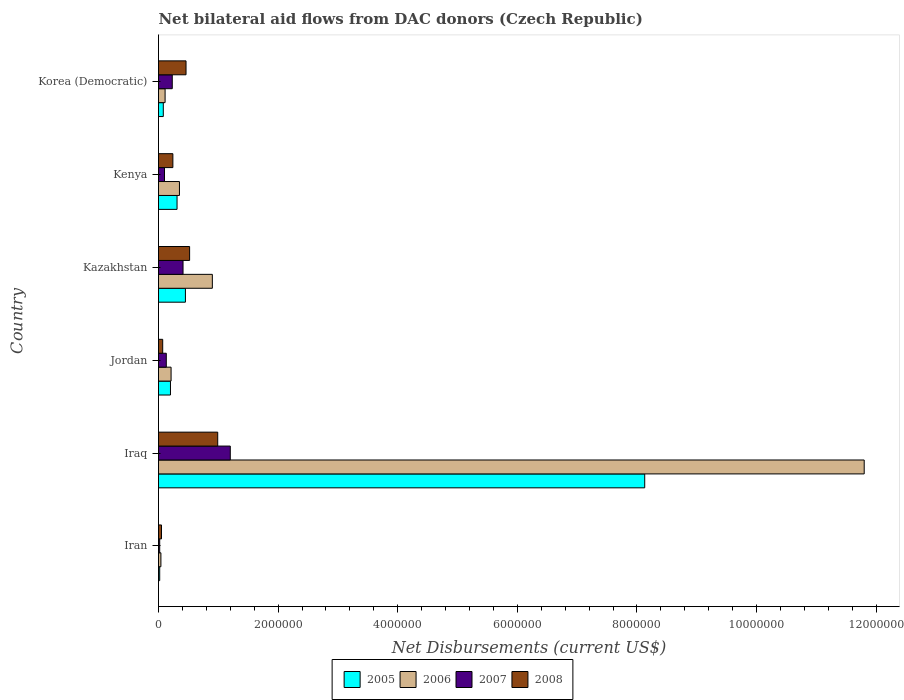How many groups of bars are there?
Your response must be concise. 6. Are the number of bars per tick equal to the number of legend labels?
Your answer should be very brief. Yes. How many bars are there on the 3rd tick from the bottom?
Your response must be concise. 4. What is the label of the 3rd group of bars from the top?
Provide a short and direct response. Kazakhstan. In how many cases, is the number of bars for a given country not equal to the number of legend labels?
Offer a very short reply. 0. What is the net bilateral aid flows in 2006 in Iraq?
Offer a very short reply. 1.18e+07. Across all countries, what is the maximum net bilateral aid flows in 2008?
Provide a succinct answer. 9.90e+05. In which country was the net bilateral aid flows in 2005 maximum?
Your answer should be compact. Iraq. In which country was the net bilateral aid flows in 2006 minimum?
Provide a succinct answer. Iran. What is the total net bilateral aid flows in 2006 in the graph?
Give a very brief answer. 1.34e+07. What is the difference between the net bilateral aid flows in 2005 in Jordan and that in Korea (Democratic)?
Your answer should be very brief. 1.20e+05. What is the difference between the net bilateral aid flows in 2008 in Kazakhstan and the net bilateral aid flows in 2005 in Korea (Democratic)?
Make the answer very short. 4.40e+05. What is the average net bilateral aid flows in 2007 per country?
Offer a terse response. 3.48e+05. In how many countries, is the net bilateral aid flows in 2005 greater than 8800000 US$?
Ensure brevity in your answer.  0. What is the ratio of the net bilateral aid flows in 2005 in Jordan to that in Kazakhstan?
Make the answer very short. 0.44. Is the difference between the net bilateral aid flows in 2005 in Iraq and Kazakhstan greater than the difference between the net bilateral aid flows in 2006 in Iraq and Kazakhstan?
Your answer should be very brief. No. What is the difference between the highest and the second highest net bilateral aid flows in 2008?
Your answer should be compact. 4.70e+05. What is the difference between the highest and the lowest net bilateral aid flows in 2007?
Keep it short and to the point. 1.18e+06. Is the sum of the net bilateral aid flows in 2006 in Kazakhstan and Kenya greater than the maximum net bilateral aid flows in 2007 across all countries?
Offer a very short reply. Yes. What does the 4th bar from the bottom in Kenya represents?
Provide a succinct answer. 2008. How many countries are there in the graph?
Your response must be concise. 6. What is the difference between two consecutive major ticks on the X-axis?
Your response must be concise. 2.00e+06. Does the graph contain grids?
Provide a succinct answer. No. Where does the legend appear in the graph?
Offer a very short reply. Bottom center. How many legend labels are there?
Your answer should be compact. 4. What is the title of the graph?
Make the answer very short. Net bilateral aid flows from DAC donors (Czech Republic). What is the label or title of the X-axis?
Your response must be concise. Net Disbursements (current US$). What is the Net Disbursements (current US$) in 2005 in Iran?
Your answer should be very brief. 2.00e+04. What is the Net Disbursements (current US$) in 2006 in Iran?
Keep it short and to the point. 4.00e+04. What is the Net Disbursements (current US$) of 2008 in Iran?
Provide a succinct answer. 5.00e+04. What is the Net Disbursements (current US$) in 2005 in Iraq?
Make the answer very short. 8.13e+06. What is the Net Disbursements (current US$) of 2006 in Iraq?
Provide a succinct answer. 1.18e+07. What is the Net Disbursements (current US$) in 2007 in Iraq?
Provide a succinct answer. 1.20e+06. What is the Net Disbursements (current US$) of 2008 in Iraq?
Ensure brevity in your answer.  9.90e+05. What is the Net Disbursements (current US$) in 2005 in Jordan?
Offer a terse response. 2.00e+05. What is the Net Disbursements (current US$) of 2007 in Jordan?
Offer a terse response. 1.30e+05. What is the Net Disbursements (current US$) of 2005 in Kazakhstan?
Provide a succinct answer. 4.50e+05. What is the Net Disbursements (current US$) in 2006 in Kazakhstan?
Your answer should be very brief. 9.00e+05. What is the Net Disbursements (current US$) of 2008 in Kazakhstan?
Your answer should be compact. 5.20e+05. What is the Net Disbursements (current US$) of 2006 in Kenya?
Provide a succinct answer. 3.50e+05. What is the Net Disbursements (current US$) of 2007 in Korea (Democratic)?
Give a very brief answer. 2.30e+05. Across all countries, what is the maximum Net Disbursements (current US$) of 2005?
Offer a very short reply. 8.13e+06. Across all countries, what is the maximum Net Disbursements (current US$) in 2006?
Your answer should be very brief. 1.18e+07. Across all countries, what is the maximum Net Disbursements (current US$) of 2007?
Your answer should be compact. 1.20e+06. Across all countries, what is the maximum Net Disbursements (current US$) in 2008?
Your answer should be very brief. 9.90e+05. Across all countries, what is the minimum Net Disbursements (current US$) in 2005?
Offer a very short reply. 2.00e+04. Across all countries, what is the minimum Net Disbursements (current US$) of 2006?
Your answer should be compact. 4.00e+04. Across all countries, what is the minimum Net Disbursements (current US$) in 2007?
Make the answer very short. 2.00e+04. Across all countries, what is the minimum Net Disbursements (current US$) in 2008?
Provide a succinct answer. 5.00e+04. What is the total Net Disbursements (current US$) of 2005 in the graph?
Your answer should be compact. 9.19e+06. What is the total Net Disbursements (current US$) of 2006 in the graph?
Keep it short and to the point. 1.34e+07. What is the total Net Disbursements (current US$) of 2007 in the graph?
Make the answer very short. 2.09e+06. What is the total Net Disbursements (current US$) of 2008 in the graph?
Provide a succinct answer. 2.33e+06. What is the difference between the Net Disbursements (current US$) in 2005 in Iran and that in Iraq?
Ensure brevity in your answer.  -8.11e+06. What is the difference between the Net Disbursements (current US$) in 2006 in Iran and that in Iraq?
Make the answer very short. -1.18e+07. What is the difference between the Net Disbursements (current US$) of 2007 in Iran and that in Iraq?
Offer a very short reply. -1.18e+06. What is the difference between the Net Disbursements (current US$) of 2008 in Iran and that in Iraq?
Provide a succinct answer. -9.40e+05. What is the difference between the Net Disbursements (current US$) of 2005 in Iran and that in Jordan?
Your answer should be compact. -1.80e+05. What is the difference between the Net Disbursements (current US$) of 2006 in Iran and that in Jordan?
Your response must be concise. -1.70e+05. What is the difference between the Net Disbursements (current US$) in 2008 in Iran and that in Jordan?
Ensure brevity in your answer.  -2.00e+04. What is the difference between the Net Disbursements (current US$) of 2005 in Iran and that in Kazakhstan?
Provide a short and direct response. -4.30e+05. What is the difference between the Net Disbursements (current US$) of 2006 in Iran and that in Kazakhstan?
Provide a succinct answer. -8.60e+05. What is the difference between the Net Disbursements (current US$) of 2007 in Iran and that in Kazakhstan?
Your answer should be compact. -3.90e+05. What is the difference between the Net Disbursements (current US$) of 2008 in Iran and that in Kazakhstan?
Your answer should be compact. -4.70e+05. What is the difference between the Net Disbursements (current US$) in 2006 in Iran and that in Kenya?
Provide a short and direct response. -3.10e+05. What is the difference between the Net Disbursements (current US$) in 2007 in Iran and that in Kenya?
Offer a terse response. -8.00e+04. What is the difference between the Net Disbursements (current US$) in 2005 in Iran and that in Korea (Democratic)?
Provide a succinct answer. -6.00e+04. What is the difference between the Net Disbursements (current US$) in 2006 in Iran and that in Korea (Democratic)?
Your answer should be compact. -7.00e+04. What is the difference between the Net Disbursements (current US$) of 2007 in Iran and that in Korea (Democratic)?
Offer a very short reply. -2.10e+05. What is the difference between the Net Disbursements (current US$) of 2008 in Iran and that in Korea (Democratic)?
Make the answer very short. -4.10e+05. What is the difference between the Net Disbursements (current US$) of 2005 in Iraq and that in Jordan?
Your answer should be very brief. 7.93e+06. What is the difference between the Net Disbursements (current US$) in 2006 in Iraq and that in Jordan?
Your answer should be very brief. 1.16e+07. What is the difference between the Net Disbursements (current US$) in 2007 in Iraq and that in Jordan?
Your response must be concise. 1.07e+06. What is the difference between the Net Disbursements (current US$) of 2008 in Iraq and that in Jordan?
Your answer should be compact. 9.20e+05. What is the difference between the Net Disbursements (current US$) of 2005 in Iraq and that in Kazakhstan?
Provide a succinct answer. 7.68e+06. What is the difference between the Net Disbursements (current US$) of 2006 in Iraq and that in Kazakhstan?
Provide a succinct answer. 1.09e+07. What is the difference between the Net Disbursements (current US$) in 2007 in Iraq and that in Kazakhstan?
Your answer should be very brief. 7.90e+05. What is the difference between the Net Disbursements (current US$) of 2005 in Iraq and that in Kenya?
Provide a succinct answer. 7.82e+06. What is the difference between the Net Disbursements (current US$) of 2006 in Iraq and that in Kenya?
Keep it short and to the point. 1.14e+07. What is the difference between the Net Disbursements (current US$) of 2007 in Iraq and that in Kenya?
Provide a short and direct response. 1.10e+06. What is the difference between the Net Disbursements (current US$) of 2008 in Iraq and that in Kenya?
Your answer should be very brief. 7.50e+05. What is the difference between the Net Disbursements (current US$) in 2005 in Iraq and that in Korea (Democratic)?
Offer a very short reply. 8.05e+06. What is the difference between the Net Disbursements (current US$) in 2006 in Iraq and that in Korea (Democratic)?
Provide a succinct answer. 1.17e+07. What is the difference between the Net Disbursements (current US$) in 2007 in Iraq and that in Korea (Democratic)?
Ensure brevity in your answer.  9.70e+05. What is the difference between the Net Disbursements (current US$) of 2008 in Iraq and that in Korea (Democratic)?
Provide a succinct answer. 5.30e+05. What is the difference between the Net Disbursements (current US$) in 2006 in Jordan and that in Kazakhstan?
Ensure brevity in your answer.  -6.90e+05. What is the difference between the Net Disbursements (current US$) in 2007 in Jordan and that in Kazakhstan?
Offer a very short reply. -2.80e+05. What is the difference between the Net Disbursements (current US$) of 2008 in Jordan and that in Kazakhstan?
Keep it short and to the point. -4.50e+05. What is the difference between the Net Disbursements (current US$) in 2005 in Jordan and that in Korea (Democratic)?
Provide a short and direct response. 1.20e+05. What is the difference between the Net Disbursements (current US$) in 2006 in Jordan and that in Korea (Democratic)?
Your response must be concise. 1.00e+05. What is the difference between the Net Disbursements (current US$) in 2008 in Jordan and that in Korea (Democratic)?
Offer a very short reply. -3.90e+05. What is the difference between the Net Disbursements (current US$) of 2006 in Kazakhstan and that in Kenya?
Provide a short and direct response. 5.50e+05. What is the difference between the Net Disbursements (current US$) of 2007 in Kazakhstan and that in Kenya?
Your response must be concise. 3.10e+05. What is the difference between the Net Disbursements (current US$) of 2006 in Kazakhstan and that in Korea (Democratic)?
Give a very brief answer. 7.90e+05. What is the difference between the Net Disbursements (current US$) of 2007 in Kazakhstan and that in Korea (Democratic)?
Your answer should be compact. 1.80e+05. What is the difference between the Net Disbursements (current US$) in 2008 in Kazakhstan and that in Korea (Democratic)?
Offer a terse response. 6.00e+04. What is the difference between the Net Disbursements (current US$) in 2006 in Kenya and that in Korea (Democratic)?
Your answer should be very brief. 2.40e+05. What is the difference between the Net Disbursements (current US$) in 2008 in Kenya and that in Korea (Democratic)?
Make the answer very short. -2.20e+05. What is the difference between the Net Disbursements (current US$) of 2005 in Iran and the Net Disbursements (current US$) of 2006 in Iraq?
Keep it short and to the point. -1.18e+07. What is the difference between the Net Disbursements (current US$) in 2005 in Iran and the Net Disbursements (current US$) in 2007 in Iraq?
Ensure brevity in your answer.  -1.18e+06. What is the difference between the Net Disbursements (current US$) of 2005 in Iran and the Net Disbursements (current US$) of 2008 in Iraq?
Offer a very short reply. -9.70e+05. What is the difference between the Net Disbursements (current US$) in 2006 in Iran and the Net Disbursements (current US$) in 2007 in Iraq?
Your response must be concise. -1.16e+06. What is the difference between the Net Disbursements (current US$) in 2006 in Iran and the Net Disbursements (current US$) in 2008 in Iraq?
Your response must be concise. -9.50e+05. What is the difference between the Net Disbursements (current US$) in 2007 in Iran and the Net Disbursements (current US$) in 2008 in Iraq?
Give a very brief answer. -9.70e+05. What is the difference between the Net Disbursements (current US$) of 2005 in Iran and the Net Disbursements (current US$) of 2006 in Jordan?
Your answer should be very brief. -1.90e+05. What is the difference between the Net Disbursements (current US$) in 2005 in Iran and the Net Disbursements (current US$) in 2008 in Jordan?
Your answer should be compact. -5.00e+04. What is the difference between the Net Disbursements (current US$) in 2006 in Iran and the Net Disbursements (current US$) in 2007 in Jordan?
Your response must be concise. -9.00e+04. What is the difference between the Net Disbursements (current US$) in 2006 in Iran and the Net Disbursements (current US$) in 2008 in Jordan?
Offer a very short reply. -3.00e+04. What is the difference between the Net Disbursements (current US$) in 2005 in Iran and the Net Disbursements (current US$) in 2006 in Kazakhstan?
Give a very brief answer. -8.80e+05. What is the difference between the Net Disbursements (current US$) of 2005 in Iran and the Net Disbursements (current US$) of 2007 in Kazakhstan?
Offer a very short reply. -3.90e+05. What is the difference between the Net Disbursements (current US$) in 2005 in Iran and the Net Disbursements (current US$) in 2008 in Kazakhstan?
Offer a terse response. -5.00e+05. What is the difference between the Net Disbursements (current US$) of 2006 in Iran and the Net Disbursements (current US$) of 2007 in Kazakhstan?
Provide a short and direct response. -3.70e+05. What is the difference between the Net Disbursements (current US$) in 2006 in Iran and the Net Disbursements (current US$) in 2008 in Kazakhstan?
Offer a terse response. -4.80e+05. What is the difference between the Net Disbursements (current US$) of 2007 in Iran and the Net Disbursements (current US$) of 2008 in Kazakhstan?
Offer a terse response. -5.00e+05. What is the difference between the Net Disbursements (current US$) of 2005 in Iran and the Net Disbursements (current US$) of 2006 in Kenya?
Make the answer very short. -3.30e+05. What is the difference between the Net Disbursements (current US$) in 2005 in Iran and the Net Disbursements (current US$) in 2007 in Kenya?
Make the answer very short. -8.00e+04. What is the difference between the Net Disbursements (current US$) in 2005 in Iran and the Net Disbursements (current US$) in 2008 in Kenya?
Provide a succinct answer. -2.20e+05. What is the difference between the Net Disbursements (current US$) of 2006 in Iran and the Net Disbursements (current US$) of 2007 in Kenya?
Your answer should be compact. -6.00e+04. What is the difference between the Net Disbursements (current US$) of 2007 in Iran and the Net Disbursements (current US$) of 2008 in Kenya?
Keep it short and to the point. -2.20e+05. What is the difference between the Net Disbursements (current US$) in 2005 in Iran and the Net Disbursements (current US$) in 2006 in Korea (Democratic)?
Keep it short and to the point. -9.00e+04. What is the difference between the Net Disbursements (current US$) of 2005 in Iran and the Net Disbursements (current US$) of 2008 in Korea (Democratic)?
Offer a terse response. -4.40e+05. What is the difference between the Net Disbursements (current US$) of 2006 in Iran and the Net Disbursements (current US$) of 2007 in Korea (Democratic)?
Provide a succinct answer. -1.90e+05. What is the difference between the Net Disbursements (current US$) of 2006 in Iran and the Net Disbursements (current US$) of 2008 in Korea (Democratic)?
Your answer should be very brief. -4.20e+05. What is the difference between the Net Disbursements (current US$) of 2007 in Iran and the Net Disbursements (current US$) of 2008 in Korea (Democratic)?
Ensure brevity in your answer.  -4.40e+05. What is the difference between the Net Disbursements (current US$) in 2005 in Iraq and the Net Disbursements (current US$) in 2006 in Jordan?
Offer a terse response. 7.92e+06. What is the difference between the Net Disbursements (current US$) of 2005 in Iraq and the Net Disbursements (current US$) of 2007 in Jordan?
Offer a very short reply. 8.00e+06. What is the difference between the Net Disbursements (current US$) of 2005 in Iraq and the Net Disbursements (current US$) of 2008 in Jordan?
Offer a very short reply. 8.06e+06. What is the difference between the Net Disbursements (current US$) of 2006 in Iraq and the Net Disbursements (current US$) of 2007 in Jordan?
Your answer should be compact. 1.17e+07. What is the difference between the Net Disbursements (current US$) of 2006 in Iraq and the Net Disbursements (current US$) of 2008 in Jordan?
Keep it short and to the point. 1.17e+07. What is the difference between the Net Disbursements (current US$) in 2007 in Iraq and the Net Disbursements (current US$) in 2008 in Jordan?
Provide a short and direct response. 1.13e+06. What is the difference between the Net Disbursements (current US$) in 2005 in Iraq and the Net Disbursements (current US$) in 2006 in Kazakhstan?
Your response must be concise. 7.23e+06. What is the difference between the Net Disbursements (current US$) in 2005 in Iraq and the Net Disbursements (current US$) in 2007 in Kazakhstan?
Provide a short and direct response. 7.72e+06. What is the difference between the Net Disbursements (current US$) of 2005 in Iraq and the Net Disbursements (current US$) of 2008 in Kazakhstan?
Your answer should be very brief. 7.61e+06. What is the difference between the Net Disbursements (current US$) in 2006 in Iraq and the Net Disbursements (current US$) in 2007 in Kazakhstan?
Your answer should be compact. 1.14e+07. What is the difference between the Net Disbursements (current US$) of 2006 in Iraq and the Net Disbursements (current US$) of 2008 in Kazakhstan?
Your response must be concise. 1.13e+07. What is the difference between the Net Disbursements (current US$) in 2007 in Iraq and the Net Disbursements (current US$) in 2008 in Kazakhstan?
Your answer should be very brief. 6.80e+05. What is the difference between the Net Disbursements (current US$) in 2005 in Iraq and the Net Disbursements (current US$) in 2006 in Kenya?
Your answer should be compact. 7.78e+06. What is the difference between the Net Disbursements (current US$) of 2005 in Iraq and the Net Disbursements (current US$) of 2007 in Kenya?
Give a very brief answer. 8.03e+06. What is the difference between the Net Disbursements (current US$) in 2005 in Iraq and the Net Disbursements (current US$) in 2008 in Kenya?
Give a very brief answer. 7.89e+06. What is the difference between the Net Disbursements (current US$) in 2006 in Iraq and the Net Disbursements (current US$) in 2007 in Kenya?
Your answer should be very brief. 1.17e+07. What is the difference between the Net Disbursements (current US$) of 2006 in Iraq and the Net Disbursements (current US$) of 2008 in Kenya?
Make the answer very short. 1.16e+07. What is the difference between the Net Disbursements (current US$) of 2007 in Iraq and the Net Disbursements (current US$) of 2008 in Kenya?
Your answer should be very brief. 9.60e+05. What is the difference between the Net Disbursements (current US$) of 2005 in Iraq and the Net Disbursements (current US$) of 2006 in Korea (Democratic)?
Give a very brief answer. 8.02e+06. What is the difference between the Net Disbursements (current US$) of 2005 in Iraq and the Net Disbursements (current US$) of 2007 in Korea (Democratic)?
Keep it short and to the point. 7.90e+06. What is the difference between the Net Disbursements (current US$) in 2005 in Iraq and the Net Disbursements (current US$) in 2008 in Korea (Democratic)?
Give a very brief answer. 7.67e+06. What is the difference between the Net Disbursements (current US$) of 2006 in Iraq and the Net Disbursements (current US$) of 2007 in Korea (Democratic)?
Provide a succinct answer. 1.16e+07. What is the difference between the Net Disbursements (current US$) in 2006 in Iraq and the Net Disbursements (current US$) in 2008 in Korea (Democratic)?
Give a very brief answer. 1.13e+07. What is the difference between the Net Disbursements (current US$) of 2007 in Iraq and the Net Disbursements (current US$) of 2008 in Korea (Democratic)?
Provide a succinct answer. 7.40e+05. What is the difference between the Net Disbursements (current US$) of 2005 in Jordan and the Net Disbursements (current US$) of 2006 in Kazakhstan?
Your answer should be compact. -7.00e+05. What is the difference between the Net Disbursements (current US$) of 2005 in Jordan and the Net Disbursements (current US$) of 2007 in Kazakhstan?
Keep it short and to the point. -2.10e+05. What is the difference between the Net Disbursements (current US$) in 2005 in Jordan and the Net Disbursements (current US$) in 2008 in Kazakhstan?
Offer a terse response. -3.20e+05. What is the difference between the Net Disbursements (current US$) in 2006 in Jordan and the Net Disbursements (current US$) in 2008 in Kazakhstan?
Offer a very short reply. -3.10e+05. What is the difference between the Net Disbursements (current US$) in 2007 in Jordan and the Net Disbursements (current US$) in 2008 in Kazakhstan?
Ensure brevity in your answer.  -3.90e+05. What is the difference between the Net Disbursements (current US$) in 2005 in Jordan and the Net Disbursements (current US$) in 2006 in Kenya?
Offer a very short reply. -1.50e+05. What is the difference between the Net Disbursements (current US$) of 2005 in Jordan and the Net Disbursements (current US$) of 2008 in Kenya?
Provide a short and direct response. -4.00e+04. What is the difference between the Net Disbursements (current US$) of 2006 in Jordan and the Net Disbursements (current US$) of 2008 in Kenya?
Give a very brief answer. -3.00e+04. What is the difference between the Net Disbursements (current US$) in 2005 in Jordan and the Net Disbursements (current US$) in 2007 in Korea (Democratic)?
Give a very brief answer. -3.00e+04. What is the difference between the Net Disbursements (current US$) of 2006 in Jordan and the Net Disbursements (current US$) of 2007 in Korea (Democratic)?
Offer a terse response. -2.00e+04. What is the difference between the Net Disbursements (current US$) in 2007 in Jordan and the Net Disbursements (current US$) in 2008 in Korea (Democratic)?
Make the answer very short. -3.30e+05. What is the difference between the Net Disbursements (current US$) in 2005 in Kazakhstan and the Net Disbursements (current US$) in 2007 in Kenya?
Your answer should be very brief. 3.50e+05. What is the difference between the Net Disbursements (current US$) in 2005 in Kazakhstan and the Net Disbursements (current US$) in 2008 in Kenya?
Keep it short and to the point. 2.10e+05. What is the difference between the Net Disbursements (current US$) in 2006 in Kazakhstan and the Net Disbursements (current US$) in 2007 in Kenya?
Provide a short and direct response. 8.00e+05. What is the difference between the Net Disbursements (current US$) of 2005 in Kazakhstan and the Net Disbursements (current US$) of 2008 in Korea (Democratic)?
Your response must be concise. -10000. What is the difference between the Net Disbursements (current US$) of 2006 in Kazakhstan and the Net Disbursements (current US$) of 2007 in Korea (Democratic)?
Offer a terse response. 6.70e+05. What is the difference between the Net Disbursements (current US$) in 2006 in Kazakhstan and the Net Disbursements (current US$) in 2008 in Korea (Democratic)?
Your answer should be very brief. 4.40e+05. What is the difference between the Net Disbursements (current US$) of 2007 in Kazakhstan and the Net Disbursements (current US$) of 2008 in Korea (Democratic)?
Keep it short and to the point. -5.00e+04. What is the difference between the Net Disbursements (current US$) in 2005 in Kenya and the Net Disbursements (current US$) in 2006 in Korea (Democratic)?
Ensure brevity in your answer.  2.00e+05. What is the difference between the Net Disbursements (current US$) in 2005 in Kenya and the Net Disbursements (current US$) in 2007 in Korea (Democratic)?
Keep it short and to the point. 8.00e+04. What is the difference between the Net Disbursements (current US$) in 2005 in Kenya and the Net Disbursements (current US$) in 2008 in Korea (Democratic)?
Make the answer very short. -1.50e+05. What is the difference between the Net Disbursements (current US$) in 2006 in Kenya and the Net Disbursements (current US$) in 2007 in Korea (Democratic)?
Provide a succinct answer. 1.20e+05. What is the difference between the Net Disbursements (current US$) in 2007 in Kenya and the Net Disbursements (current US$) in 2008 in Korea (Democratic)?
Give a very brief answer. -3.60e+05. What is the average Net Disbursements (current US$) in 2005 per country?
Provide a succinct answer. 1.53e+06. What is the average Net Disbursements (current US$) in 2006 per country?
Keep it short and to the point. 2.24e+06. What is the average Net Disbursements (current US$) of 2007 per country?
Give a very brief answer. 3.48e+05. What is the average Net Disbursements (current US$) in 2008 per country?
Give a very brief answer. 3.88e+05. What is the difference between the Net Disbursements (current US$) of 2005 and Net Disbursements (current US$) of 2006 in Iran?
Your answer should be compact. -2.00e+04. What is the difference between the Net Disbursements (current US$) in 2006 and Net Disbursements (current US$) in 2008 in Iran?
Your response must be concise. -10000. What is the difference between the Net Disbursements (current US$) in 2007 and Net Disbursements (current US$) in 2008 in Iran?
Your answer should be very brief. -3.00e+04. What is the difference between the Net Disbursements (current US$) of 2005 and Net Disbursements (current US$) of 2006 in Iraq?
Ensure brevity in your answer.  -3.67e+06. What is the difference between the Net Disbursements (current US$) in 2005 and Net Disbursements (current US$) in 2007 in Iraq?
Your response must be concise. 6.93e+06. What is the difference between the Net Disbursements (current US$) of 2005 and Net Disbursements (current US$) of 2008 in Iraq?
Provide a succinct answer. 7.14e+06. What is the difference between the Net Disbursements (current US$) in 2006 and Net Disbursements (current US$) in 2007 in Iraq?
Offer a very short reply. 1.06e+07. What is the difference between the Net Disbursements (current US$) in 2006 and Net Disbursements (current US$) in 2008 in Iraq?
Your answer should be compact. 1.08e+07. What is the difference between the Net Disbursements (current US$) in 2007 and Net Disbursements (current US$) in 2008 in Iraq?
Your response must be concise. 2.10e+05. What is the difference between the Net Disbursements (current US$) of 2005 and Net Disbursements (current US$) of 2008 in Jordan?
Give a very brief answer. 1.30e+05. What is the difference between the Net Disbursements (current US$) of 2007 and Net Disbursements (current US$) of 2008 in Jordan?
Ensure brevity in your answer.  6.00e+04. What is the difference between the Net Disbursements (current US$) of 2005 and Net Disbursements (current US$) of 2006 in Kazakhstan?
Your answer should be compact. -4.50e+05. What is the difference between the Net Disbursements (current US$) of 2005 and Net Disbursements (current US$) of 2006 in Kenya?
Provide a succinct answer. -4.00e+04. What is the difference between the Net Disbursements (current US$) of 2006 and Net Disbursements (current US$) of 2007 in Kenya?
Offer a terse response. 2.50e+05. What is the difference between the Net Disbursements (current US$) of 2006 and Net Disbursements (current US$) of 2008 in Kenya?
Provide a succinct answer. 1.10e+05. What is the difference between the Net Disbursements (current US$) in 2007 and Net Disbursements (current US$) in 2008 in Kenya?
Keep it short and to the point. -1.40e+05. What is the difference between the Net Disbursements (current US$) of 2005 and Net Disbursements (current US$) of 2006 in Korea (Democratic)?
Provide a short and direct response. -3.00e+04. What is the difference between the Net Disbursements (current US$) in 2005 and Net Disbursements (current US$) in 2008 in Korea (Democratic)?
Your answer should be very brief. -3.80e+05. What is the difference between the Net Disbursements (current US$) in 2006 and Net Disbursements (current US$) in 2007 in Korea (Democratic)?
Your response must be concise. -1.20e+05. What is the difference between the Net Disbursements (current US$) of 2006 and Net Disbursements (current US$) of 2008 in Korea (Democratic)?
Your response must be concise. -3.50e+05. What is the difference between the Net Disbursements (current US$) of 2007 and Net Disbursements (current US$) of 2008 in Korea (Democratic)?
Offer a terse response. -2.30e+05. What is the ratio of the Net Disbursements (current US$) in 2005 in Iran to that in Iraq?
Keep it short and to the point. 0. What is the ratio of the Net Disbursements (current US$) of 2006 in Iran to that in Iraq?
Keep it short and to the point. 0. What is the ratio of the Net Disbursements (current US$) of 2007 in Iran to that in Iraq?
Keep it short and to the point. 0.02. What is the ratio of the Net Disbursements (current US$) of 2008 in Iran to that in Iraq?
Offer a very short reply. 0.05. What is the ratio of the Net Disbursements (current US$) of 2005 in Iran to that in Jordan?
Provide a succinct answer. 0.1. What is the ratio of the Net Disbursements (current US$) in 2006 in Iran to that in Jordan?
Make the answer very short. 0.19. What is the ratio of the Net Disbursements (current US$) of 2007 in Iran to that in Jordan?
Keep it short and to the point. 0.15. What is the ratio of the Net Disbursements (current US$) of 2008 in Iran to that in Jordan?
Offer a terse response. 0.71. What is the ratio of the Net Disbursements (current US$) of 2005 in Iran to that in Kazakhstan?
Offer a terse response. 0.04. What is the ratio of the Net Disbursements (current US$) of 2006 in Iran to that in Kazakhstan?
Make the answer very short. 0.04. What is the ratio of the Net Disbursements (current US$) in 2007 in Iran to that in Kazakhstan?
Provide a short and direct response. 0.05. What is the ratio of the Net Disbursements (current US$) of 2008 in Iran to that in Kazakhstan?
Provide a succinct answer. 0.1. What is the ratio of the Net Disbursements (current US$) of 2005 in Iran to that in Kenya?
Provide a succinct answer. 0.06. What is the ratio of the Net Disbursements (current US$) of 2006 in Iran to that in Kenya?
Your response must be concise. 0.11. What is the ratio of the Net Disbursements (current US$) of 2007 in Iran to that in Kenya?
Make the answer very short. 0.2. What is the ratio of the Net Disbursements (current US$) in 2008 in Iran to that in Kenya?
Make the answer very short. 0.21. What is the ratio of the Net Disbursements (current US$) of 2005 in Iran to that in Korea (Democratic)?
Ensure brevity in your answer.  0.25. What is the ratio of the Net Disbursements (current US$) in 2006 in Iran to that in Korea (Democratic)?
Your answer should be very brief. 0.36. What is the ratio of the Net Disbursements (current US$) in 2007 in Iran to that in Korea (Democratic)?
Offer a very short reply. 0.09. What is the ratio of the Net Disbursements (current US$) of 2008 in Iran to that in Korea (Democratic)?
Make the answer very short. 0.11. What is the ratio of the Net Disbursements (current US$) in 2005 in Iraq to that in Jordan?
Make the answer very short. 40.65. What is the ratio of the Net Disbursements (current US$) in 2006 in Iraq to that in Jordan?
Make the answer very short. 56.19. What is the ratio of the Net Disbursements (current US$) of 2007 in Iraq to that in Jordan?
Your answer should be very brief. 9.23. What is the ratio of the Net Disbursements (current US$) in 2008 in Iraq to that in Jordan?
Provide a short and direct response. 14.14. What is the ratio of the Net Disbursements (current US$) in 2005 in Iraq to that in Kazakhstan?
Ensure brevity in your answer.  18.07. What is the ratio of the Net Disbursements (current US$) in 2006 in Iraq to that in Kazakhstan?
Your response must be concise. 13.11. What is the ratio of the Net Disbursements (current US$) of 2007 in Iraq to that in Kazakhstan?
Ensure brevity in your answer.  2.93. What is the ratio of the Net Disbursements (current US$) of 2008 in Iraq to that in Kazakhstan?
Provide a short and direct response. 1.9. What is the ratio of the Net Disbursements (current US$) in 2005 in Iraq to that in Kenya?
Offer a terse response. 26.23. What is the ratio of the Net Disbursements (current US$) of 2006 in Iraq to that in Kenya?
Your answer should be very brief. 33.71. What is the ratio of the Net Disbursements (current US$) in 2007 in Iraq to that in Kenya?
Ensure brevity in your answer.  12. What is the ratio of the Net Disbursements (current US$) of 2008 in Iraq to that in Kenya?
Ensure brevity in your answer.  4.12. What is the ratio of the Net Disbursements (current US$) in 2005 in Iraq to that in Korea (Democratic)?
Offer a very short reply. 101.62. What is the ratio of the Net Disbursements (current US$) in 2006 in Iraq to that in Korea (Democratic)?
Ensure brevity in your answer.  107.27. What is the ratio of the Net Disbursements (current US$) in 2007 in Iraq to that in Korea (Democratic)?
Keep it short and to the point. 5.22. What is the ratio of the Net Disbursements (current US$) in 2008 in Iraq to that in Korea (Democratic)?
Keep it short and to the point. 2.15. What is the ratio of the Net Disbursements (current US$) of 2005 in Jordan to that in Kazakhstan?
Your response must be concise. 0.44. What is the ratio of the Net Disbursements (current US$) in 2006 in Jordan to that in Kazakhstan?
Make the answer very short. 0.23. What is the ratio of the Net Disbursements (current US$) in 2007 in Jordan to that in Kazakhstan?
Your answer should be very brief. 0.32. What is the ratio of the Net Disbursements (current US$) of 2008 in Jordan to that in Kazakhstan?
Give a very brief answer. 0.13. What is the ratio of the Net Disbursements (current US$) of 2005 in Jordan to that in Kenya?
Make the answer very short. 0.65. What is the ratio of the Net Disbursements (current US$) in 2007 in Jordan to that in Kenya?
Provide a short and direct response. 1.3. What is the ratio of the Net Disbursements (current US$) in 2008 in Jordan to that in Kenya?
Keep it short and to the point. 0.29. What is the ratio of the Net Disbursements (current US$) in 2005 in Jordan to that in Korea (Democratic)?
Give a very brief answer. 2.5. What is the ratio of the Net Disbursements (current US$) of 2006 in Jordan to that in Korea (Democratic)?
Make the answer very short. 1.91. What is the ratio of the Net Disbursements (current US$) of 2007 in Jordan to that in Korea (Democratic)?
Ensure brevity in your answer.  0.57. What is the ratio of the Net Disbursements (current US$) in 2008 in Jordan to that in Korea (Democratic)?
Keep it short and to the point. 0.15. What is the ratio of the Net Disbursements (current US$) of 2005 in Kazakhstan to that in Kenya?
Provide a short and direct response. 1.45. What is the ratio of the Net Disbursements (current US$) of 2006 in Kazakhstan to that in Kenya?
Give a very brief answer. 2.57. What is the ratio of the Net Disbursements (current US$) in 2007 in Kazakhstan to that in Kenya?
Offer a terse response. 4.1. What is the ratio of the Net Disbursements (current US$) of 2008 in Kazakhstan to that in Kenya?
Provide a succinct answer. 2.17. What is the ratio of the Net Disbursements (current US$) in 2005 in Kazakhstan to that in Korea (Democratic)?
Your response must be concise. 5.62. What is the ratio of the Net Disbursements (current US$) in 2006 in Kazakhstan to that in Korea (Democratic)?
Your answer should be very brief. 8.18. What is the ratio of the Net Disbursements (current US$) in 2007 in Kazakhstan to that in Korea (Democratic)?
Offer a terse response. 1.78. What is the ratio of the Net Disbursements (current US$) of 2008 in Kazakhstan to that in Korea (Democratic)?
Keep it short and to the point. 1.13. What is the ratio of the Net Disbursements (current US$) in 2005 in Kenya to that in Korea (Democratic)?
Ensure brevity in your answer.  3.88. What is the ratio of the Net Disbursements (current US$) of 2006 in Kenya to that in Korea (Democratic)?
Offer a very short reply. 3.18. What is the ratio of the Net Disbursements (current US$) of 2007 in Kenya to that in Korea (Democratic)?
Your answer should be very brief. 0.43. What is the ratio of the Net Disbursements (current US$) of 2008 in Kenya to that in Korea (Democratic)?
Provide a short and direct response. 0.52. What is the difference between the highest and the second highest Net Disbursements (current US$) of 2005?
Make the answer very short. 7.68e+06. What is the difference between the highest and the second highest Net Disbursements (current US$) in 2006?
Keep it short and to the point. 1.09e+07. What is the difference between the highest and the second highest Net Disbursements (current US$) of 2007?
Offer a very short reply. 7.90e+05. What is the difference between the highest and the second highest Net Disbursements (current US$) of 2008?
Your answer should be very brief. 4.70e+05. What is the difference between the highest and the lowest Net Disbursements (current US$) of 2005?
Your answer should be very brief. 8.11e+06. What is the difference between the highest and the lowest Net Disbursements (current US$) in 2006?
Provide a short and direct response. 1.18e+07. What is the difference between the highest and the lowest Net Disbursements (current US$) in 2007?
Offer a terse response. 1.18e+06. What is the difference between the highest and the lowest Net Disbursements (current US$) in 2008?
Keep it short and to the point. 9.40e+05. 